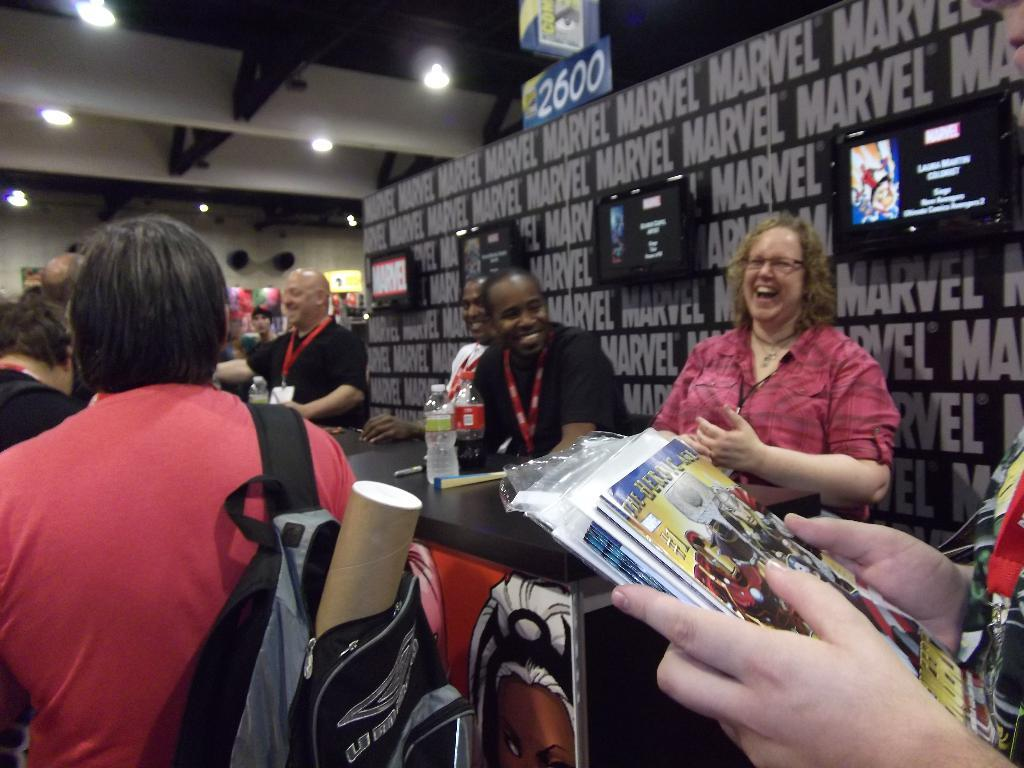<image>
Share a concise interpretation of the image provided. A board saying Marvel on it behind some people 